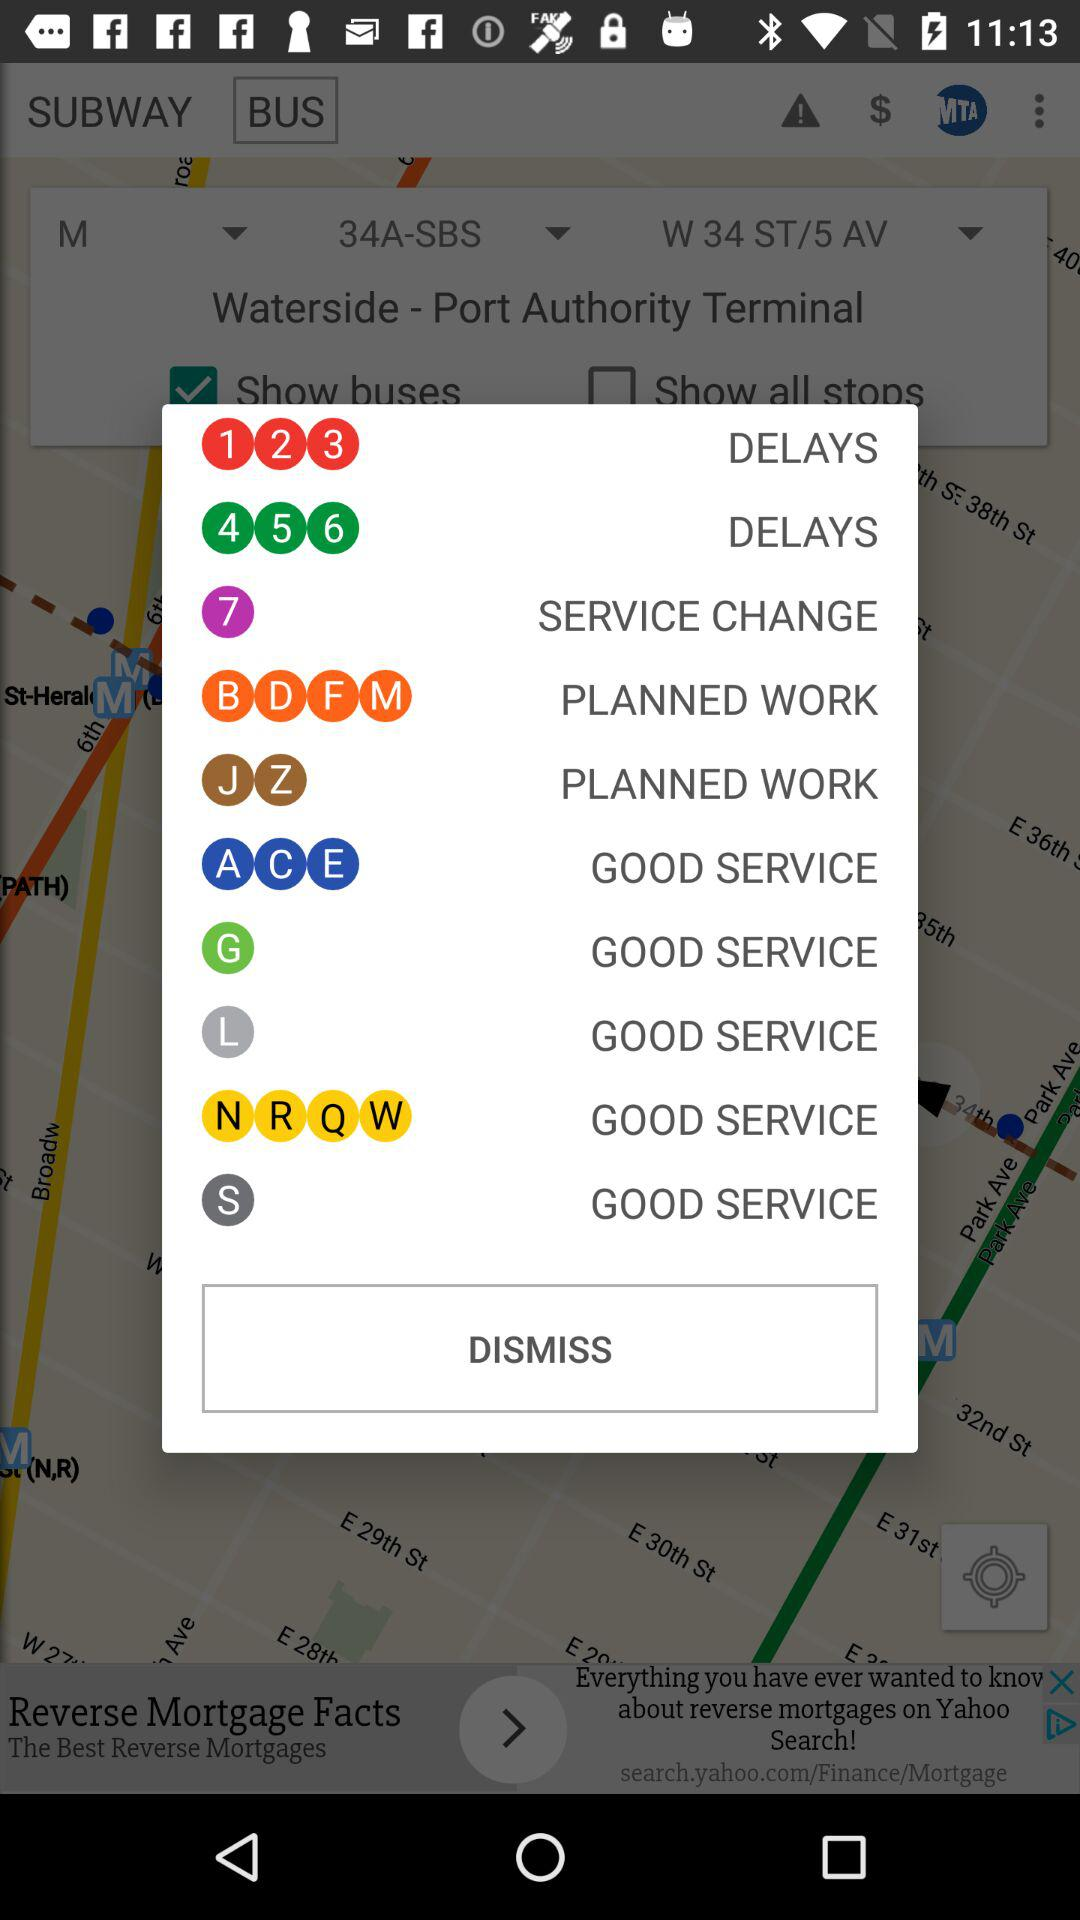How many items have the text 'DELAYS'?
Answer the question using a single word or phrase. 2 